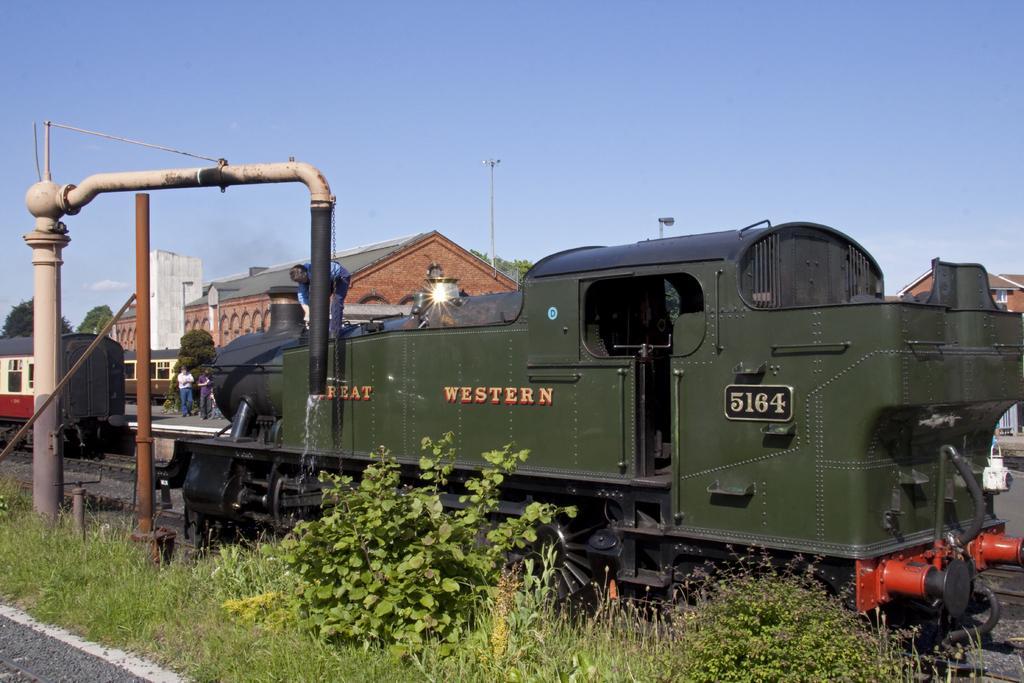Please provide a concise description of this image. In this image we can see two trains on the tracks, there are some people, poles, buildings, plants, trees and grass. In the background, we can see the sky. 